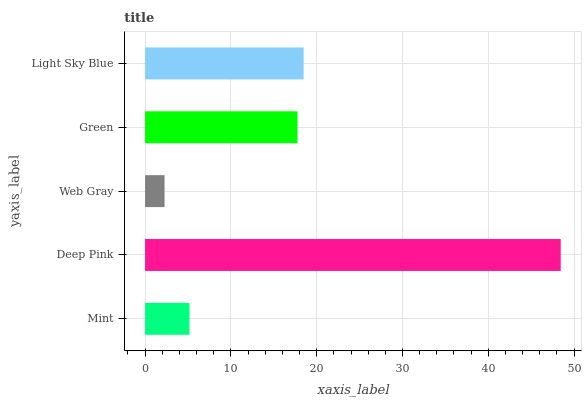Is Web Gray the minimum?
Answer yes or no. Yes. Is Deep Pink the maximum?
Answer yes or no. Yes. Is Deep Pink the minimum?
Answer yes or no. No. Is Web Gray the maximum?
Answer yes or no. No. Is Deep Pink greater than Web Gray?
Answer yes or no. Yes. Is Web Gray less than Deep Pink?
Answer yes or no. Yes. Is Web Gray greater than Deep Pink?
Answer yes or no. No. Is Deep Pink less than Web Gray?
Answer yes or no. No. Is Green the high median?
Answer yes or no. Yes. Is Green the low median?
Answer yes or no. Yes. Is Deep Pink the high median?
Answer yes or no. No. Is Mint the low median?
Answer yes or no. No. 